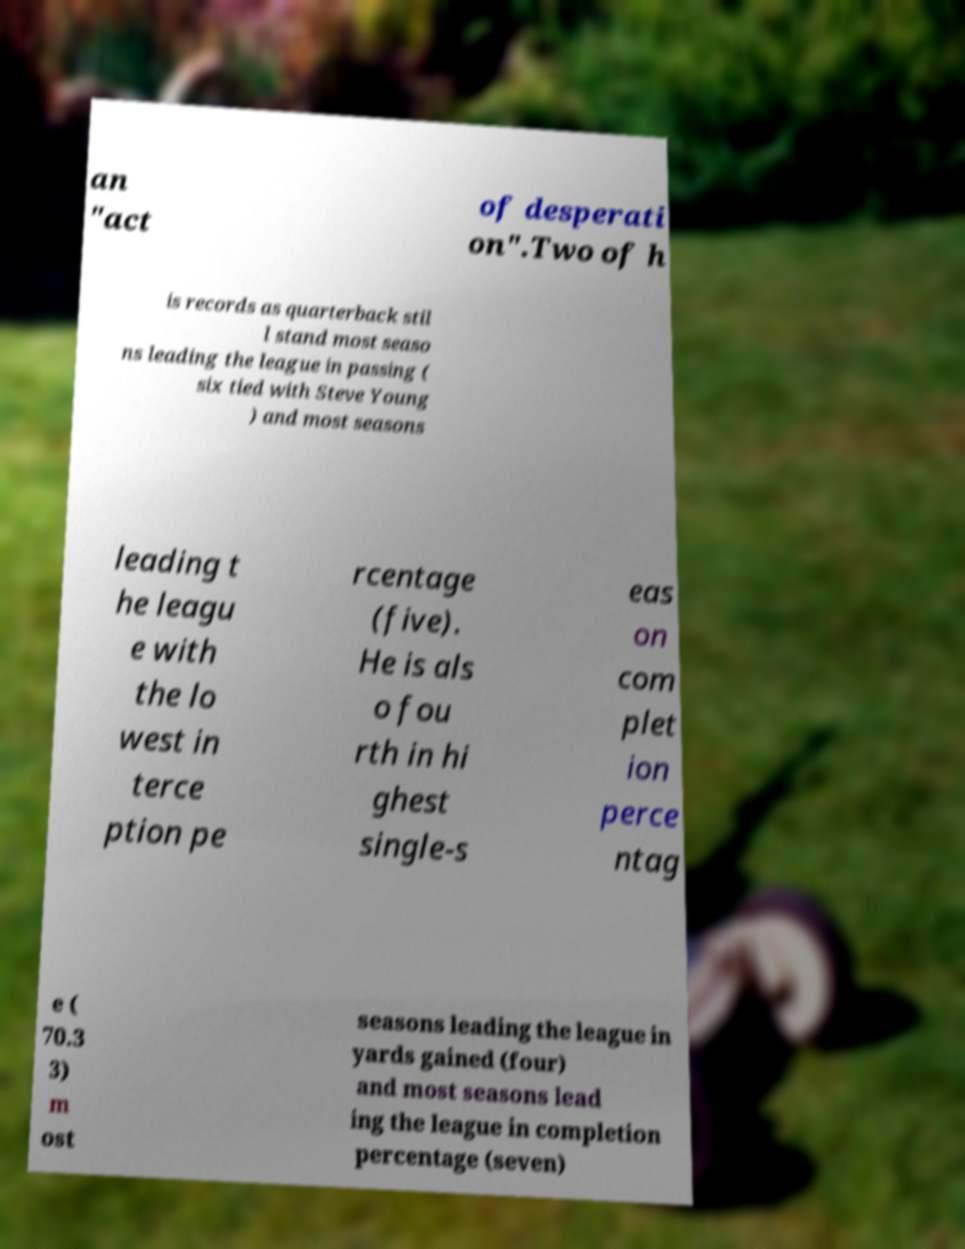Could you assist in decoding the text presented in this image and type it out clearly? an "act of desperati on".Two of h is records as quarterback stil l stand most seaso ns leading the league in passing ( six tied with Steve Young ) and most seasons leading t he leagu e with the lo west in terce ption pe rcentage (five). He is als o fou rth in hi ghest single-s eas on com plet ion perce ntag e ( 70.3 3) m ost seasons leading the league in yards gained (four) and most seasons lead ing the league in completion percentage (seven) 